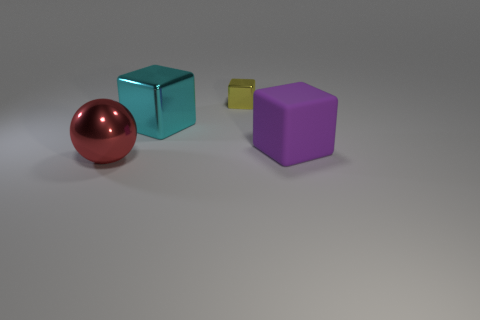What might be the relative sizes of these objects? From the perspective provided by the image, the red sphere and the purple cube appear to be the largest objects, followed by the teal cube, which is slightly smaller. The yellow cube is the smallest object among them. 